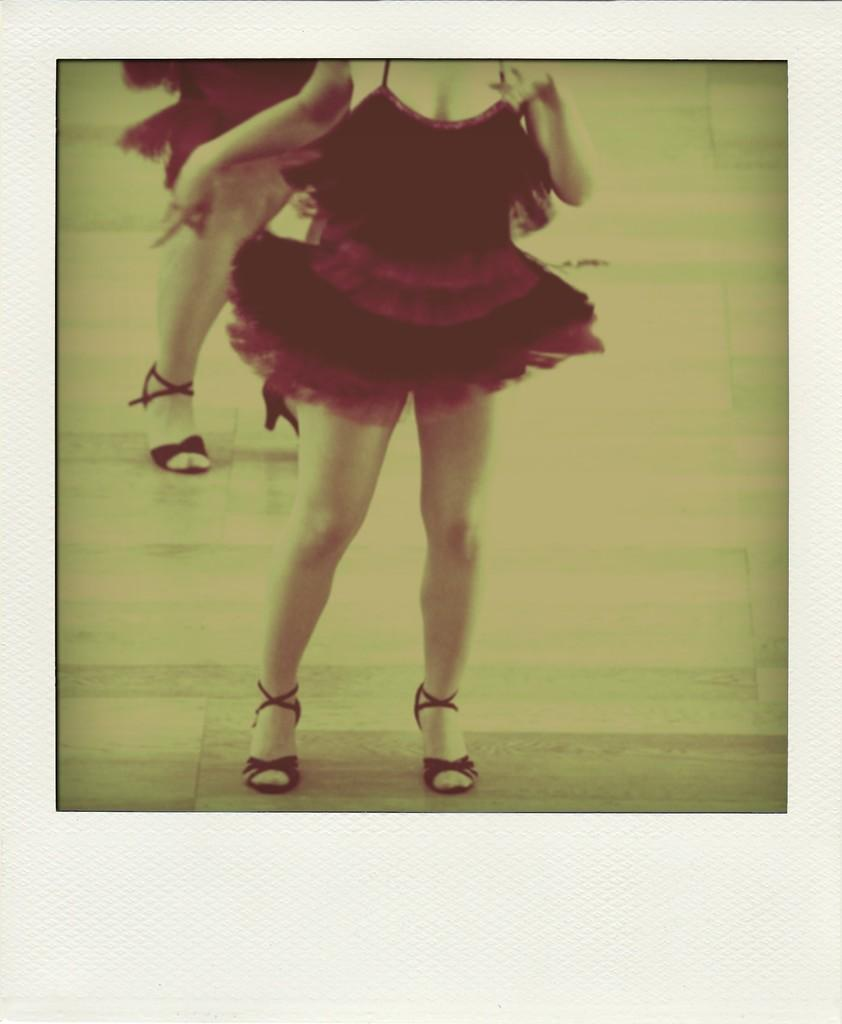How many people are in the image? There are two persons in the image. What type of footwear are the persons wearing? The persons are wearing heels. What type of clothing are the persons wearing? The persons are wearing frocks. What surface are the persons standing on? The persons are standing on the floor. What type of plastic object is being twisted by the persons in the image? There is no plastic object present in the image, nor is any twisting activity depicted. 